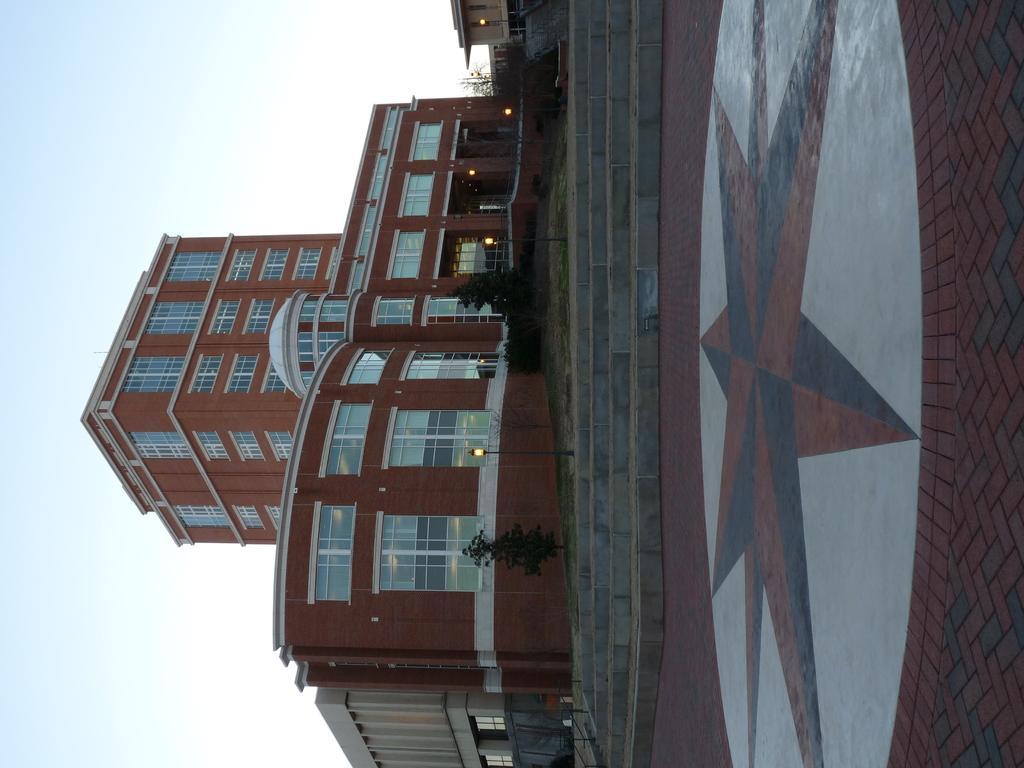In one or two sentences, can you explain what this image depicts? In this image we can see there is the building and in front of the building there are plants and stairs. And there is the ground with a design. And at the top there is the sky. 